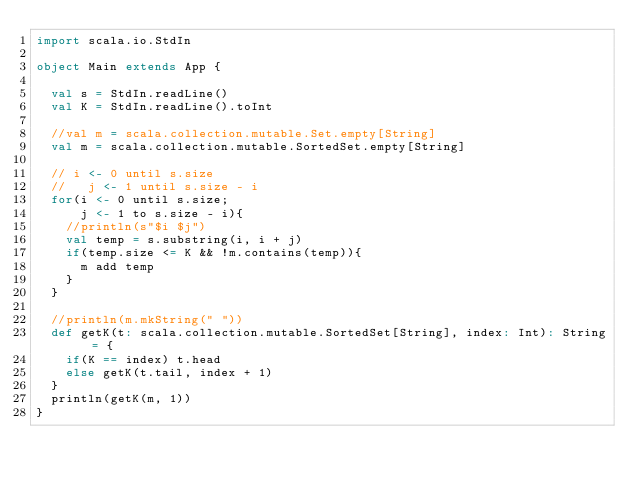<code> <loc_0><loc_0><loc_500><loc_500><_Scala_>import scala.io.StdIn

object Main extends App {

  val s = StdIn.readLine()
  val K = StdIn.readLine().toInt
  
  //val m = scala.collection.mutable.Set.empty[String]
  val m = scala.collection.mutable.SortedSet.empty[String]
  
  // i <- 0 until s.size
  //   j <- 1 until s.size - i
  for(i <- 0 until s.size;
      j <- 1 to s.size - i){
    //println(s"$i $j")
    val temp = s.substring(i, i + j)
    if(temp.size <= K && !m.contains(temp)){
      m add temp
    }
  }
  
  //println(m.mkString(" "))
  def getK(t: scala.collection.mutable.SortedSet[String], index: Int): String = {
    if(K == index) t.head
    else getK(t.tail, index + 1)
  }
  println(getK(m, 1))
}
</code> 